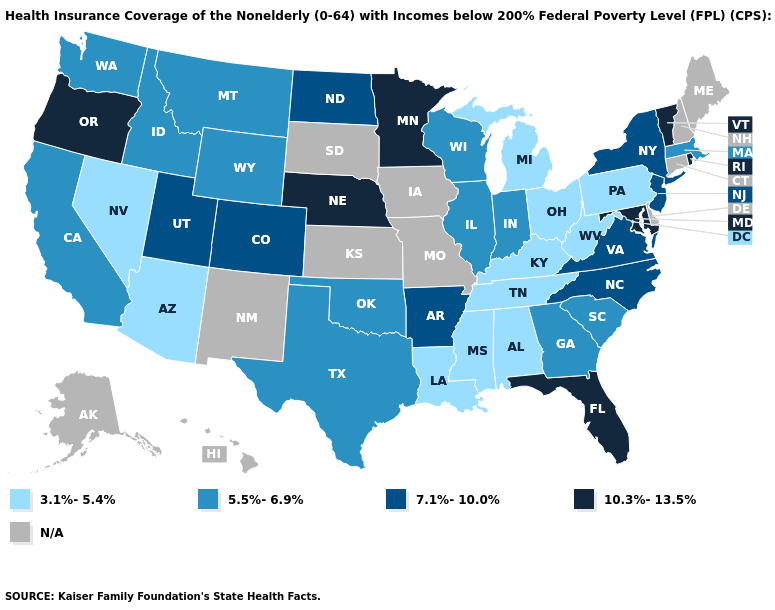Among the states that border South Carolina , which have the lowest value?
Keep it brief. Georgia. What is the value of West Virginia?
Keep it brief. 3.1%-5.4%. What is the highest value in states that border Georgia?
Keep it brief. 10.3%-13.5%. Does California have the lowest value in the USA?
Short answer required. No. Name the states that have a value in the range 10.3%-13.5%?
Give a very brief answer. Florida, Maryland, Minnesota, Nebraska, Oregon, Rhode Island, Vermont. What is the value of Illinois?
Short answer required. 5.5%-6.9%. Among the states that border Arizona , which have the lowest value?
Be succinct. Nevada. What is the value of Missouri?
Be succinct. N/A. What is the value of Hawaii?
Give a very brief answer. N/A. How many symbols are there in the legend?
Be succinct. 5. What is the value of Indiana?
Short answer required. 5.5%-6.9%. How many symbols are there in the legend?
Write a very short answer. 5. 